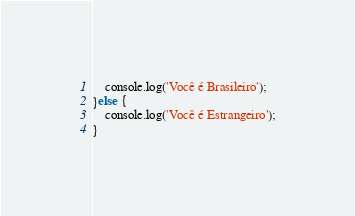Convert code to text. <code><loc_0><loc_0><loc_500><loc_500><_JavaScript_>    console.log('Você é Brasileiro');
}else {
    console.log('Você é Estrangeiro');
}</code> 